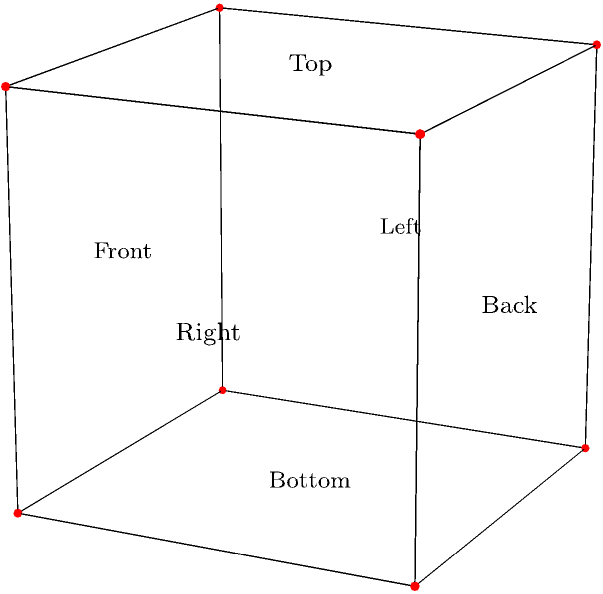As a proud and excited primary school science teacher, you're introducing your students to the fascinating world of 3D shapes. You've drawn a cube on the board, similar to the one shown above. How many faces, edges, and vertices does this cube have in total? Let's break this down step-by-step:

1. Counting faces:
   - We can see 3 faces clearly: front, top, and right.
   - The hidden faces are back, bottom, and left.
   - Total faces: $3 + 3 = 6$

2. Counting edges:
   - We can see 9 edges in the diagram.
   - There are 3 hidden edges at the back.
   - Total edges: $9 + 3 = 12$

3. Counting vertices:
   - We can see 7 vertices (corners) in the diagram.
   - There is 1 hidden vertex at the back.
   - Total vertices: $7 + 1 = 8$

4. Adding up the total:
   - Total = Faces + Edges + Vertices
   - Total = $6 + 12 + 8 = 26$

This cube follows Euler's formula for polyhedra: $V - E + F = 2$, where $V$ is the number of vertices, $E$ is the number of edges, and $F$ is the number of faces. We can verify: $8 - 12 + 6 = 2$
Answer: 26 